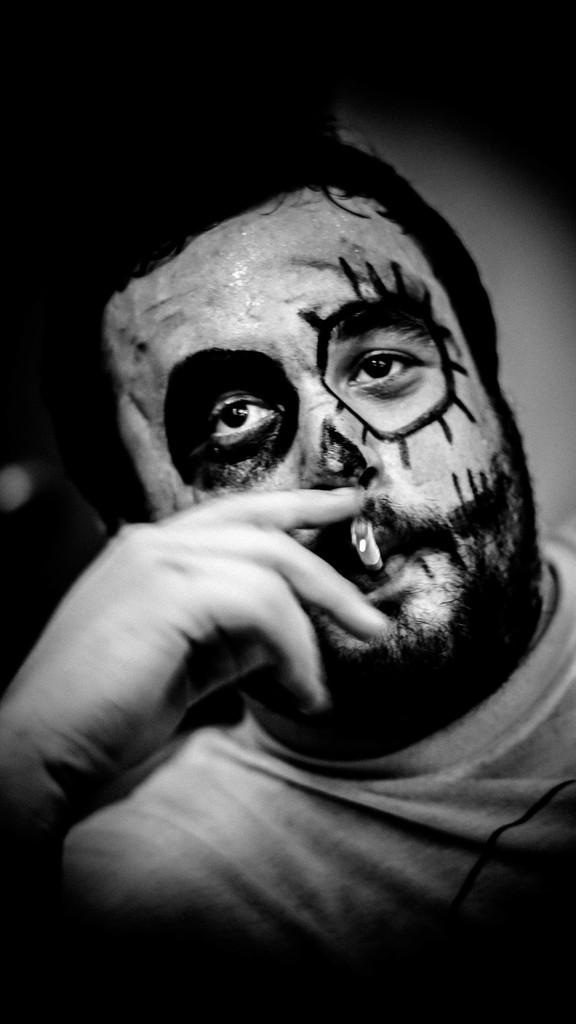What is the color scheme of the image? The image is black and white. Who is present in the image? There is a man in the image. What is the man doing in the image? The man is smoking. Can you describe any additional features on the man's face? There is a painting on the man's face. What type of ring is the man wearing on his finger in the image? There is no ring visible on the man's finger in the image. 